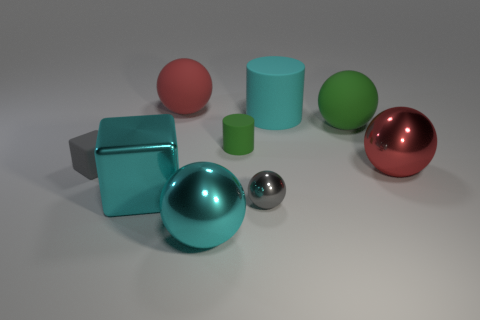What number of things are either big green objects right of the small metal sphere or tiny gray objects behind the big cyan metal block?
Keep it short and to the point. 2. How many objects are green rubber spheres or tiny purple matte cylinders?
Your response must be concise. 1. There is a red sphere on the right side of the red rubber sphere; what number of big balls are to the left of it?
Ensure brevity in your answer.  3. How many other objects are the same size as the green ball?
Make the answer very short. 5. What is the size of the sphere that is the same color as the matte cube?
Ensure brevity in your answer.  Small. Do the big cyan object that is to the right of the tiny matte cylinder and the gray shiny object have the same shape?
Provide a succinct answer. No. There is a small gray object right of the green cylinder; what material is it?
Make the answer very short. Metal. The tiny object that is the same color as the small shiny ball is what shape?
Make the answer very short. Cube. Is there a yellow cube made of the same material as the big cyan cube?
Ensure brevity in your answer.  No. The cyan shiny ball has what size?
Offer a very short reply. Large. 